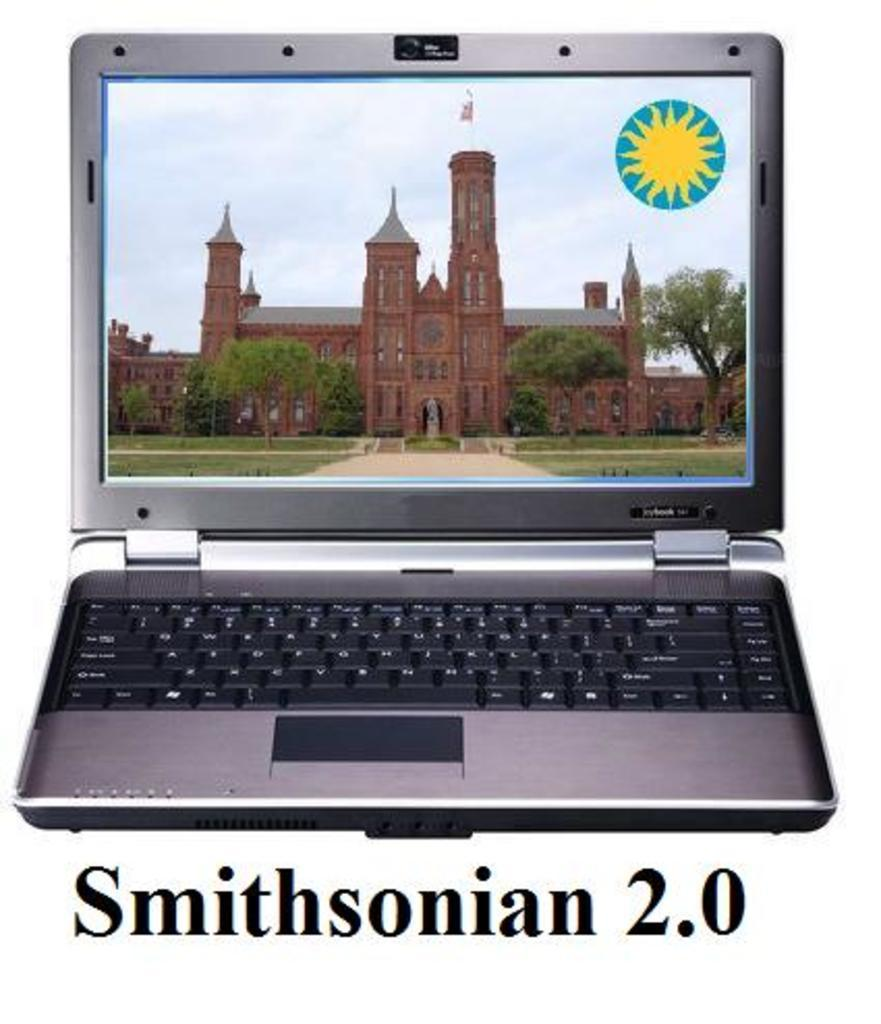What electronic device is present in the image? The image contains a laptop. What is displayed on the laptop screen? The laptop screen displays plants, a sculpture, trees, grass, a building, a flag, the sky, and watermarks. Can you describe the different elements displayed on the laptop screen? The laptop screen displays various elements, including plants, a sculpture, trees, grass, a building, a flag, the sky, and watermarks. What type of lip can be seen on the laptop screen? There is no lip present on the laptop screen; it displays various elements such as plants, a sculpture, trees, grass, a building, a flag, the sky, and watermarks. 